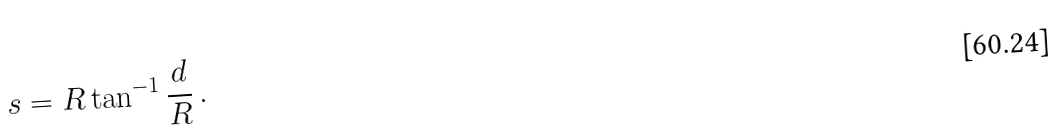Convert formula to latex. <formula><loc_0><loc_0><loc_500><loc_500>s = R \tan ^ { - 1 } { \frac { d } { R } } \, .</formula> 